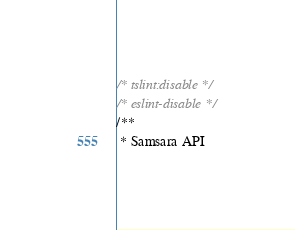Convert code to text. <code><loc_0><loc_0><loc_500><loc_500><_TypeScript_>/* tslint:disable */
/* eslint-disable */
/**
 * Samsara API</code> 